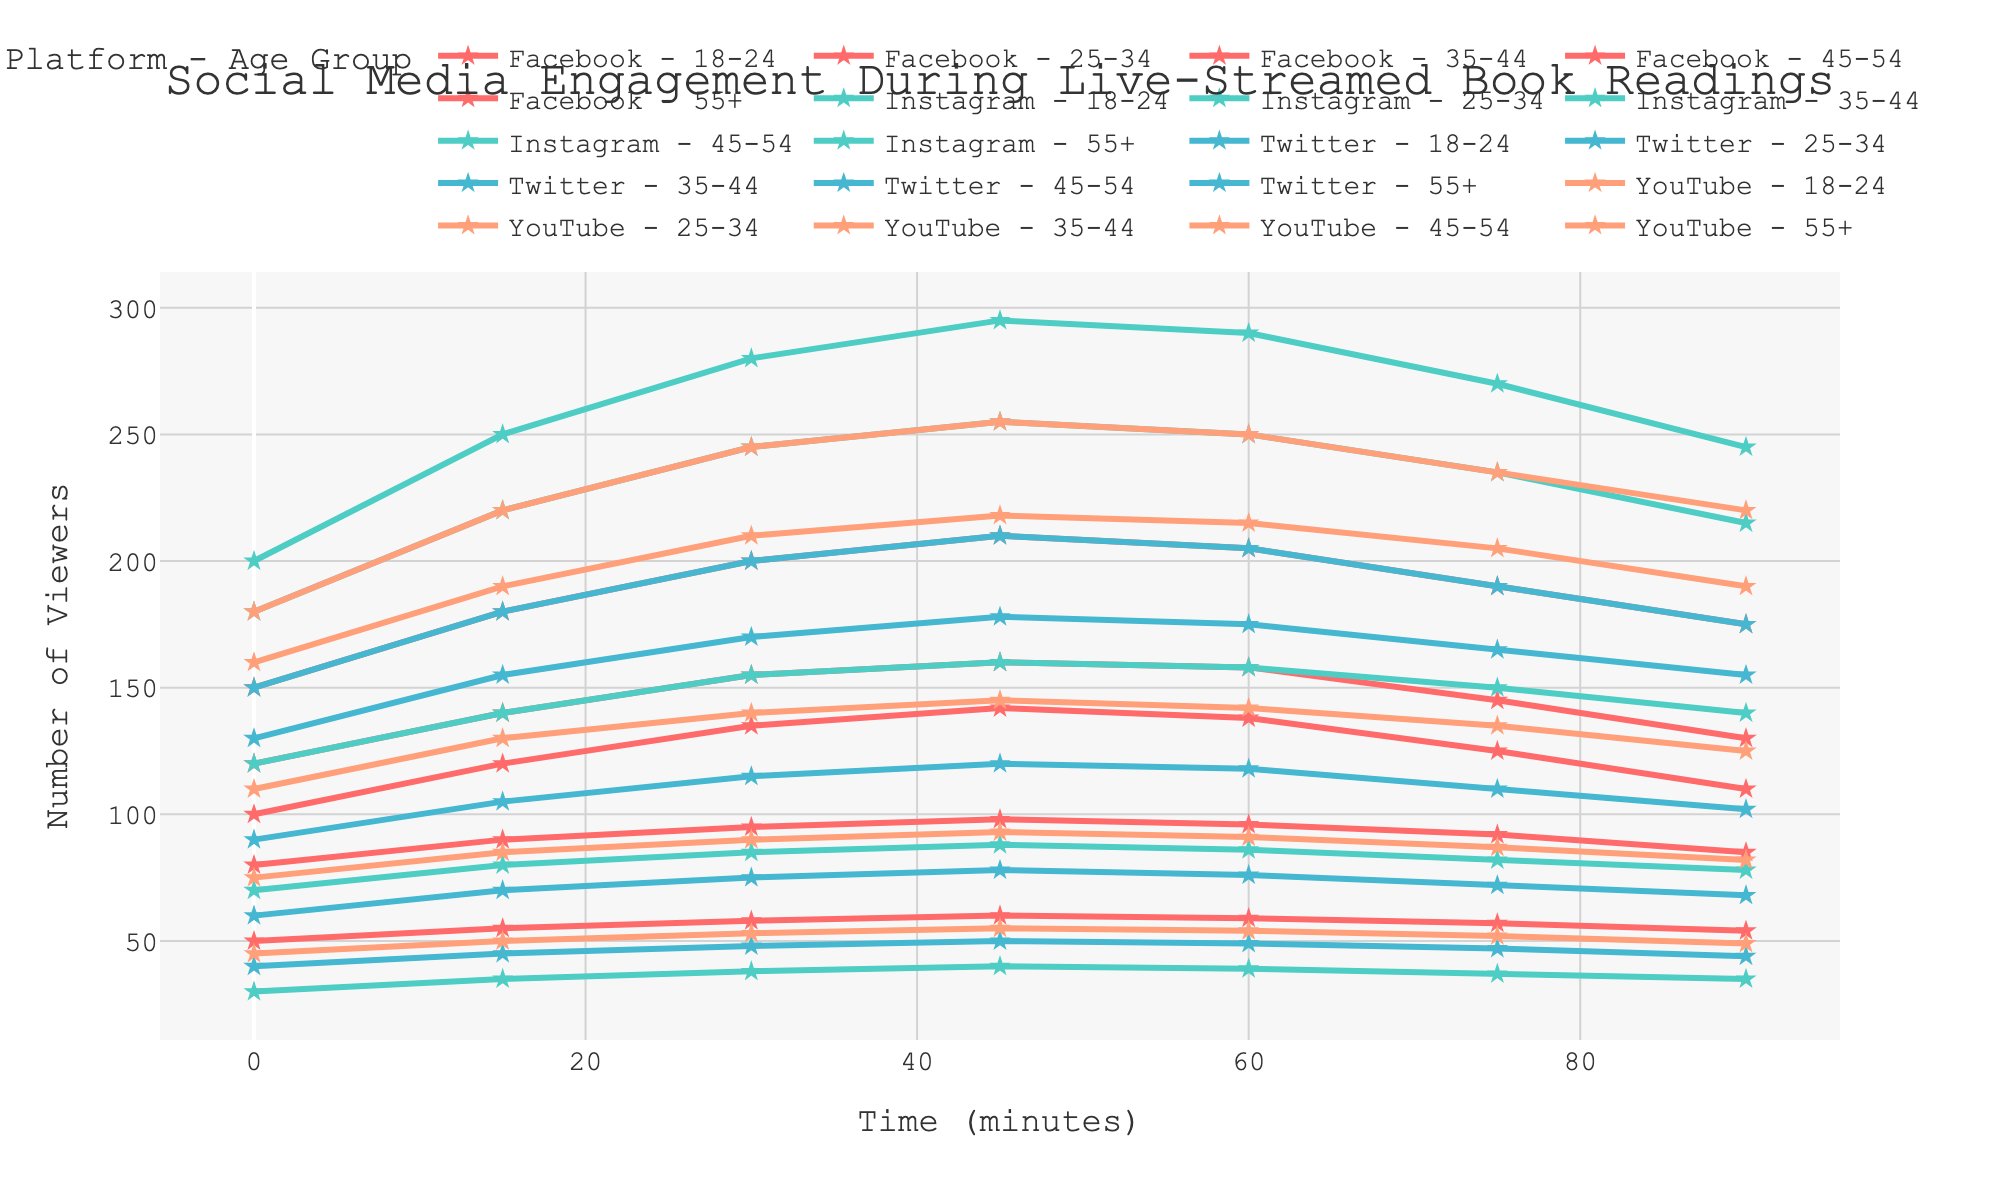How does engagement on Facebook change for the 18-24 age group over the 90 minutes? Engagement on Facebook for the 18-24 age group starts at 100 viewers, peaks at 142 viewers around 45 minutes, and then gradually declines to 110 viewers by 90 minutes.
Answer: Peaks at 45 minutes and declines Which platform and age group combination maintained the highest engagement at 60 minutes? Instagram for the 18-24 age group had the highest engagement at 60 minutes with 290 viewers.
Answer: Instagram, 18-24 From 30 to 60 minutes, which platform shows the least drop in engagement for the 25-34 age group? Facebook for the 25-34 age group has a slight decrease from 200 to 205, showing almost no drop. Other platforms see more significant decreases.
Answer: Facebook Compare the engagement trends of YouTube and Twitter for the 35-44 age group. Both YouTube and Twitter for the 35-44 age group show a steady increase in engagement up to 45 minutes and then a gradual decline. However, YouTube starts at 110 and peaks at 145, whereas Twitter starts at 90 and peaks at 120.
Answer: Similar trend, but YouTube starts and peaks higher What's the overall engagement trend for the 55+ age group across all platforms? Engagement for the 55+ age group across all platforms starts lower and shows a peak around 45-60 minutes, then slightly decreases towards 90 minutes. The engagement levels remain relatively stable with less fluctuation compared to younger age groups.
Answer: Stable, peak at 45-60 minutes, slight decrease Which age group on Instagram shows the most significant increase in engagement from the start to the peak? The 18-24 age group on Instagram shows the most significant increase, going from 200 viewers at the start to 295 viewers at its peak, an increase of 95 viewers.
Answer: 18-24 How does engagement on Twitter for the 45-54 age group compare to the 55+ age group at the end of the session (90 minutes)? At the 90-minute mark, the 45-54 age group on Twitter has 68 viewers, whereas the 55+ age group has 44 viewers, indicating that the 45-54 age group has higher engagement.
Answer: 45-54 has higher engagement What is the average engagement for the 25-34 age group across all platforms at the 75-minute mark? The engagement values at 75 minutes for the 25-34 age group across all platforms are: Facebook (190), Instagram (235), Twitter (165), and YouTube (205). The sum is 190 + 235 + 165 + 205 = 795. The average is 795 / 4 = 198.75.
Answer: 198.75 Compare the engagement peaks for the 18-24 age group on Facebook and Instagram. On Facebook, the 18-24 age group peaks at 142 viewers at 45 minutes. On Instagram, they peak higher at 295 viewers around the same time.
Answer: Instagram is higher 